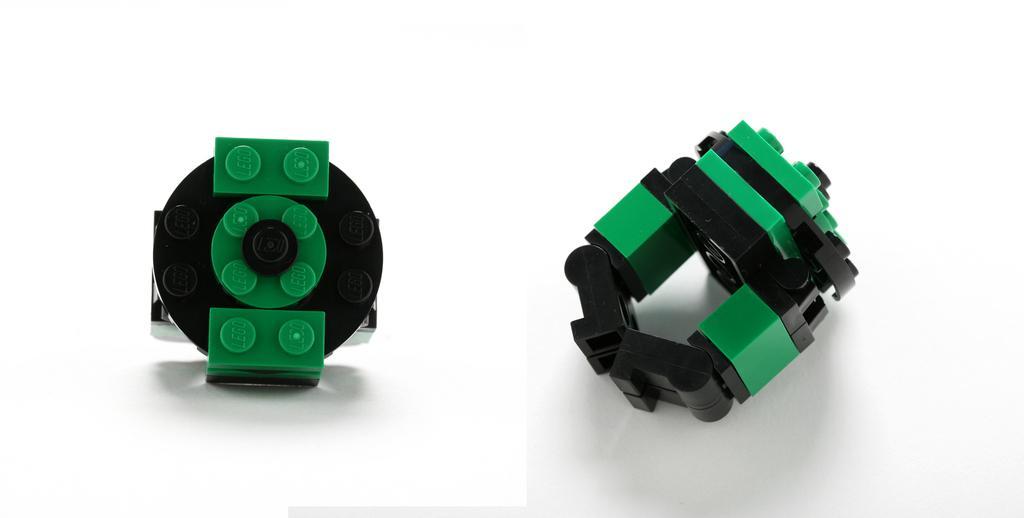Describe this image in one or two sentences. In this image I can see two toys and white color background. 